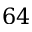Convert formula to latex. <formula><loc_0><loc_0><loc_500><loc_500>6 4</formula> 